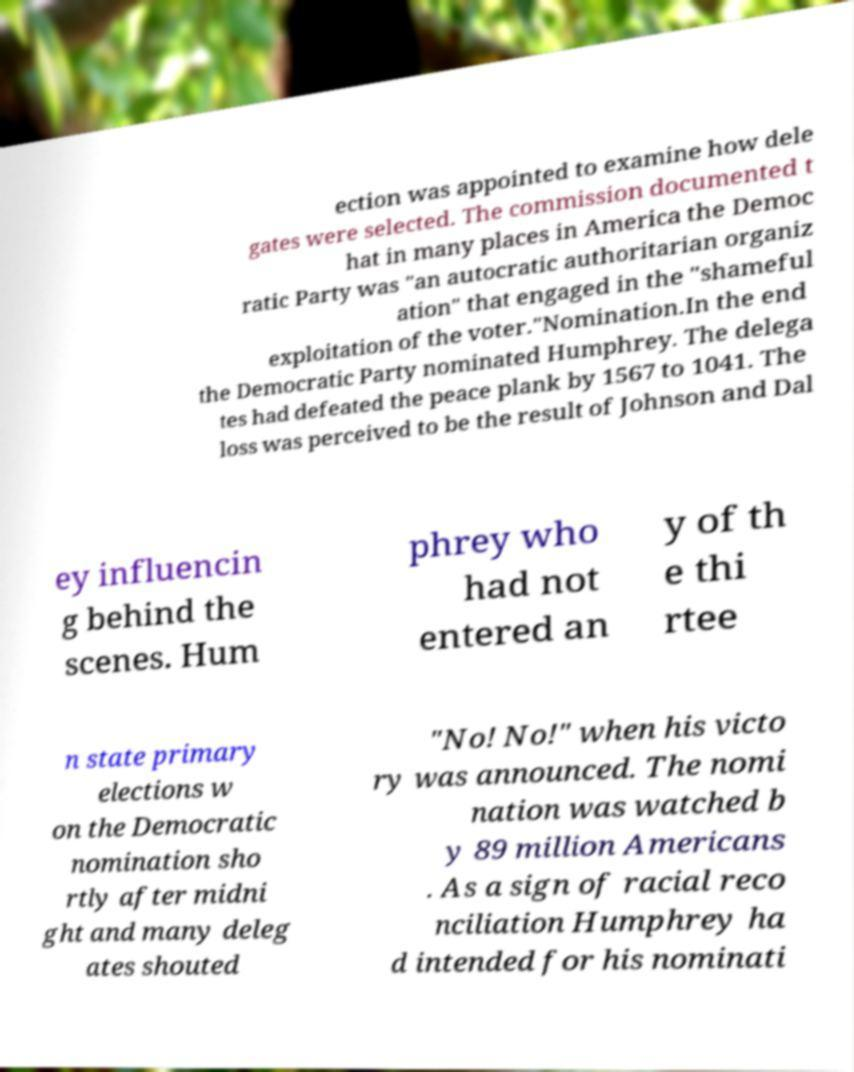Please read and relay the text visible in this image. What does it say? ection was appointed to examine how dele gates were selected. The commission documented t hat in many places in America the Democ ratic Party was "an autocratic authoritarian organiz ation" that engaged in the "shameful exploitation of the voter."Nomination.In the end the Democratic Party nominated Humphrey. The delega tes had defeated the peace plank by 1567 to 1041. The loss was perceived to be the result of Johnson and Dal ey influencin g behind the scenes. Hum phrey who had not entered an y of th e thi rtee n state primary elections w on the Democratic nomination sho rtly after midni ght and many deleg ates shouted "No! No!" when his victo ry was announced. The nomi nation was watched b y 89 million Americans . As a sign of racial reco nciliation Humphrey ha d intended for his nominati 